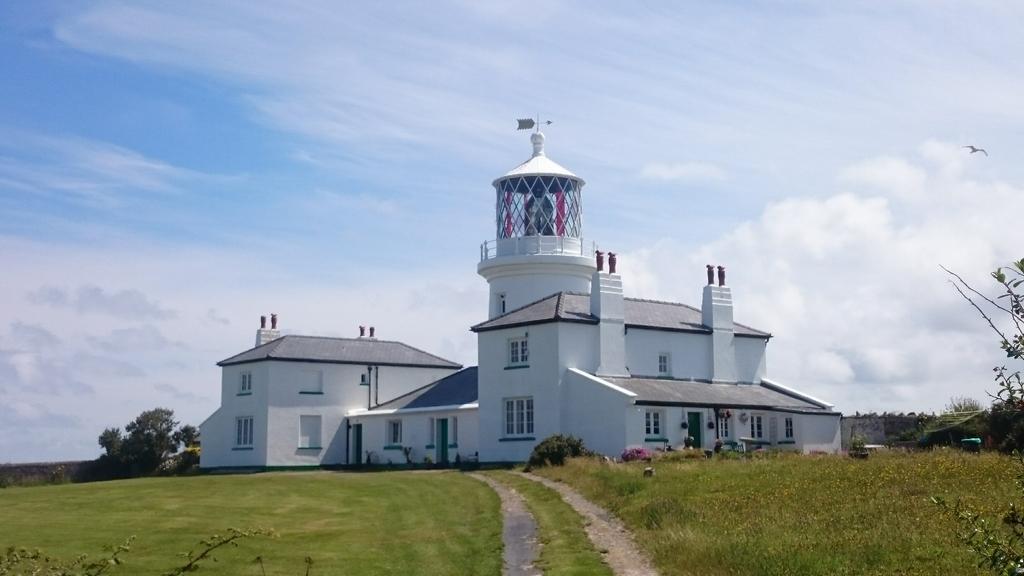How would you summarize this image in a sentence or two? In this image we can see a house and there is walkway and some grass and in the background of the image we can see some trees and clear sky. 